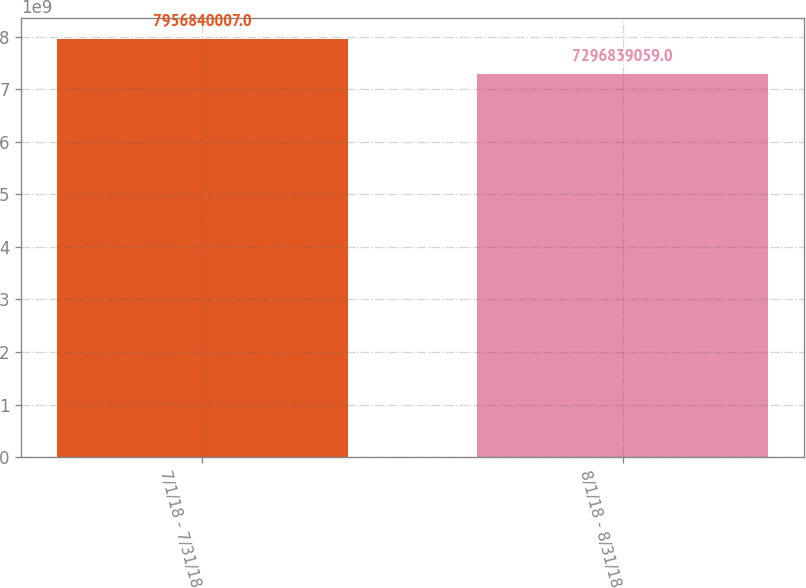Convert chart to OTSL. <chart><loc_0><loc_0><loc_500><loc_500><bar_chart><fcel>7/1/18 - 7/31/18<fcel>8/1/18 - 8/31/18<nl><fcel>7.95684e+09<fcel>7.29684e+09<nl></chart> 